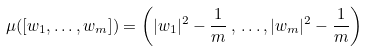Convert formula to latex. <formula><loc_0><loc_0><loc_500><loc_500>\mu ( [ w _ { 1 } , \dots , w _ { m } ] ) = \left ( | w _ { 1 } | ^ { 2 } - \frac { 1 } { m } \, , \, \dots , | w _ { m } | ^ { 2 } - \frac { 1 } { m } \right )</formula> 